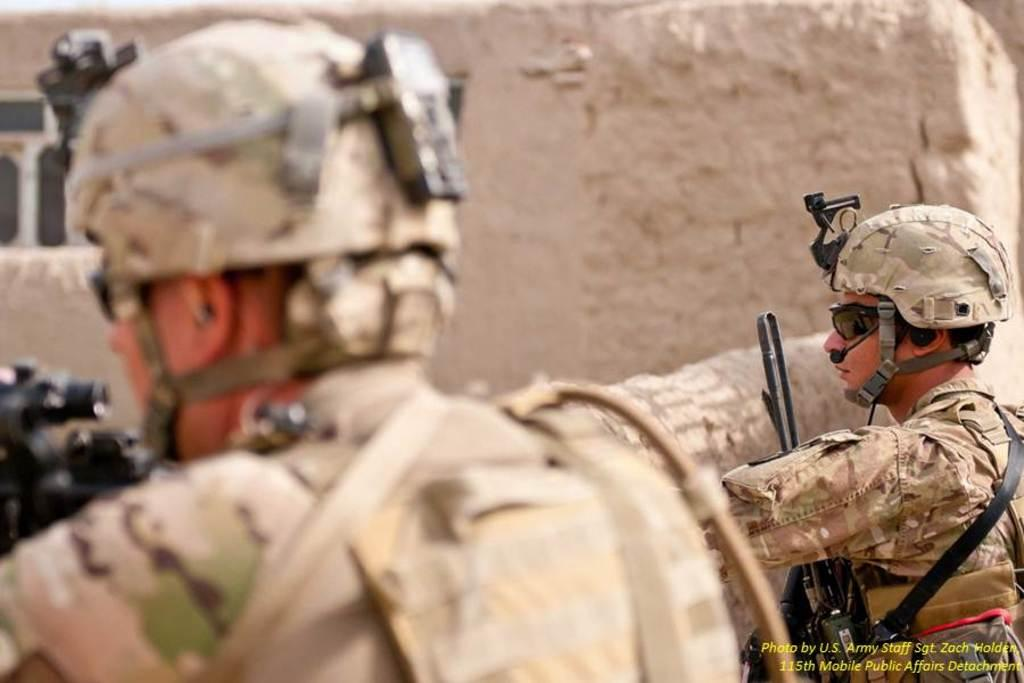How many people are in the image? There are two people in the image. What protective gear are the people wearing? Both people are wearing helmets and goggles. What are the people holding in their hands? Both people are holding guns in their hands. What can be seen in the background of the image? There is a window and walls visible in the background of the image. What type of arch can be seen in the image? There is no arch present in the image. How many shoes are visible on the people's feet in the image? The people are wearing helmets and goggles, but their feet are not visible, so we cannot determine the number of shoes. 